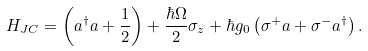Convert formula to latex. <formula><loc_0><loc_0><loc_500><loc_500>H _ { J C } = \left ( a ^ { \dagger } a + \frac { 1 } { 2 } \right ) + \frac { \hbar { \Omega } } { 2 } \sigma _ { z } + \hbar { g } _ { 0 } \left ( \sigma ^ { + } a + \sigma ^ { - } a ^ { \dagger } \right ) .</formula> 